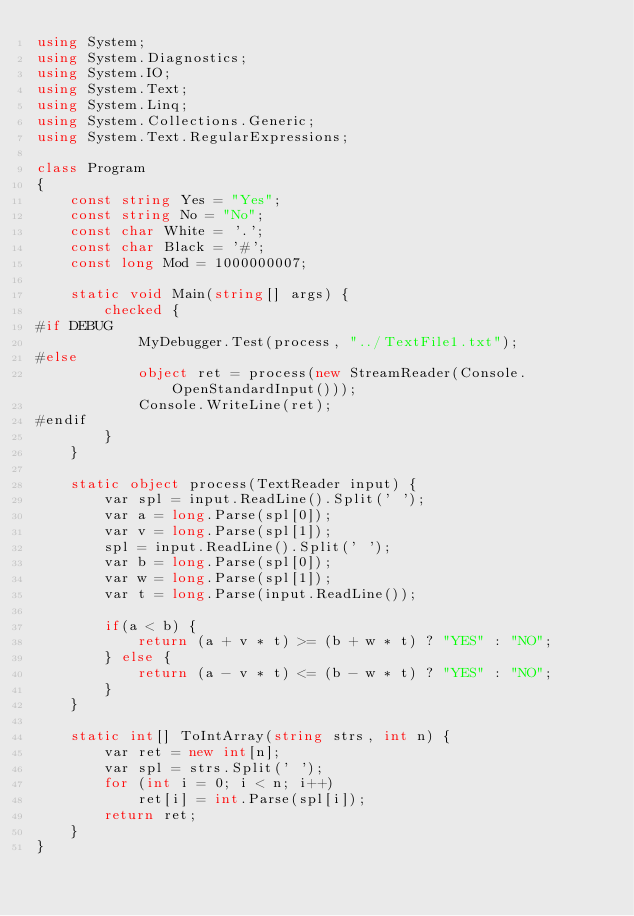<code> <loc_0><loc_0><loc_500><loc_500><_C#_>using System;
using System.Diagnostics;
using System.IO;
using System.Text;
using System.Linq;
using System.Collections.Generic;
using System.Text.RegularExpressions;

class Program
{
    const string Yes = "Yes";
    const string No = "No";
    const char White = '.';
    const char Black = '#';
    const long Mod = 1000000007;

    static void Main(string[] args) {
        checked {
#if DEBUG
            MyDebugger.Test(process, "../TextFile1.txt");
#else
            object ret = process(new StreamReader(Console.OpenStandardInput()));
            Console.WriteLine(ret);
#endif
        }
    }

    static object process(TextReader input) {
        var spl = input.ReadLine().Split(' ');
        var a = long.Parse(spl[0]);
        var v = long.Parse(spl[1]);
        spl = input.ReadLine().Split(' ');
        var b = long.Parse(spl[0]);
        var w = long.Parse(spl[1]);
        var t = long.Parse(input.ReadLine());
        
        if(a < b) {
            return (a + v * t) >= (b + w * t) ? "YES" : "NO";
        } else {
            return (a - v * t) <= (b - w * t) ? "YES" : "NO";
        }
    }

    static int[] ToIntArray(string strs, int n) {
        var ret = new int[n];
        var spl = strs.Split(' ');
        for (int i = 0; i < n; i++)
            ret[i] = int.Parse(spl[i]);
        return ret;
    }
}
</code> 